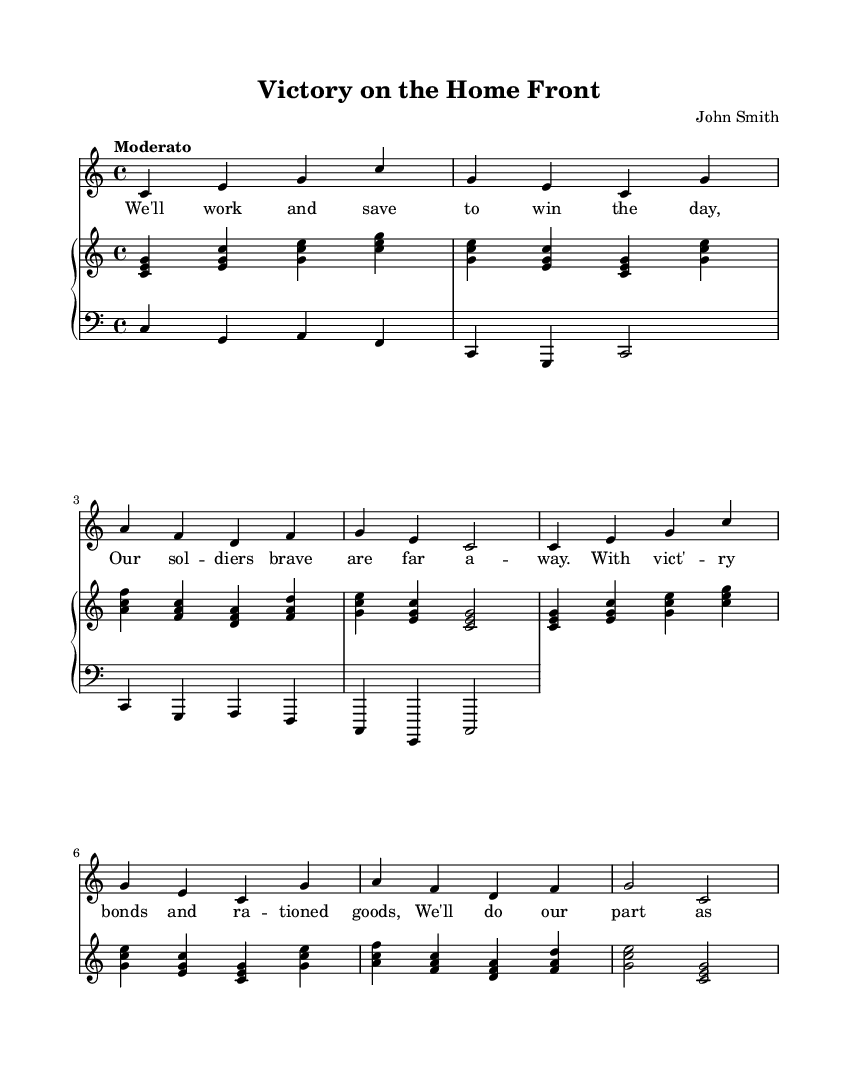What is the key signature of this music? The key signature is C major, which is indicated by the absence of sharps or flats on the staff. Since there are no accidentals shown, the piece is in the natural state of C major.
Answer: C major What is the time signature of this music? The time signature is found at the beginning of the piece, indicated as 4/4, which means there are four beats in each measure and a quarter note receives one beat.
Answer: 4/4 What is the tempo marking of the piece? The tempo marking "Moderato" is provided at the beginning of the score, indicating a moderate speed for the music.
Answer: Moderato How many measures are in the melody section? By counting the vertical lines that separate the measures in the melody part, there are a total of eight measures.
Answer: 8 What is the form of the piece? The piece follows a simple verse structure, repeated after the initial presentation, which is common in patriotic songs to reinforce themes of unity and support.
Answer: Verse-refrain What chord is indicated on the first beat of the second measure? The notes in the first chord of the second measure are G, E, and C, which form a C major chord. This is verified by examining the notes stacked in the upper staff.
Answer: C major What type of song is this piece categorized as? Given the lyrical content and the context during World War II, this song is categorized as a patriotic song, reflecting themes of support for soldiers and communal effort.
Answer: Patriotic song 